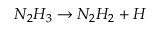<formula> <loc_0><loc_0><loc_500><loc_500>N _ { 2 } H _ { 3 } \rightarrow N _ { 2 } H _ { 2 } + H</formula> 